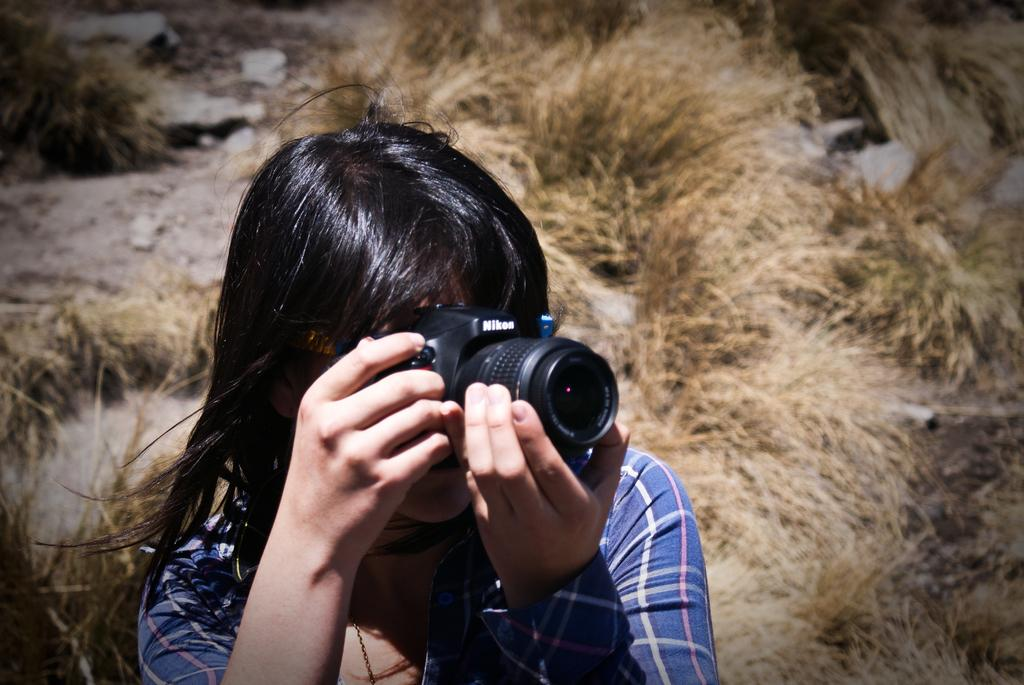What type of vegetation can be seen in the background of the image? There is dried grass in the background of the image. What other elements are present in the background of the image? There are stones in the background of the image. Who is in the image? There is a woman in the image. What is the woman doing in the image? The woman is holding a camera in her hands and taking a snapshot. What is the weather like in the image? It appears to be a sunny day. Can you see the ocean in the background of the image? No, the ocean is not present in the image. Is there a toothbrush visible in the woman's hand while she is taking the snapshot? No, there is no toothbrush visible in the image. 